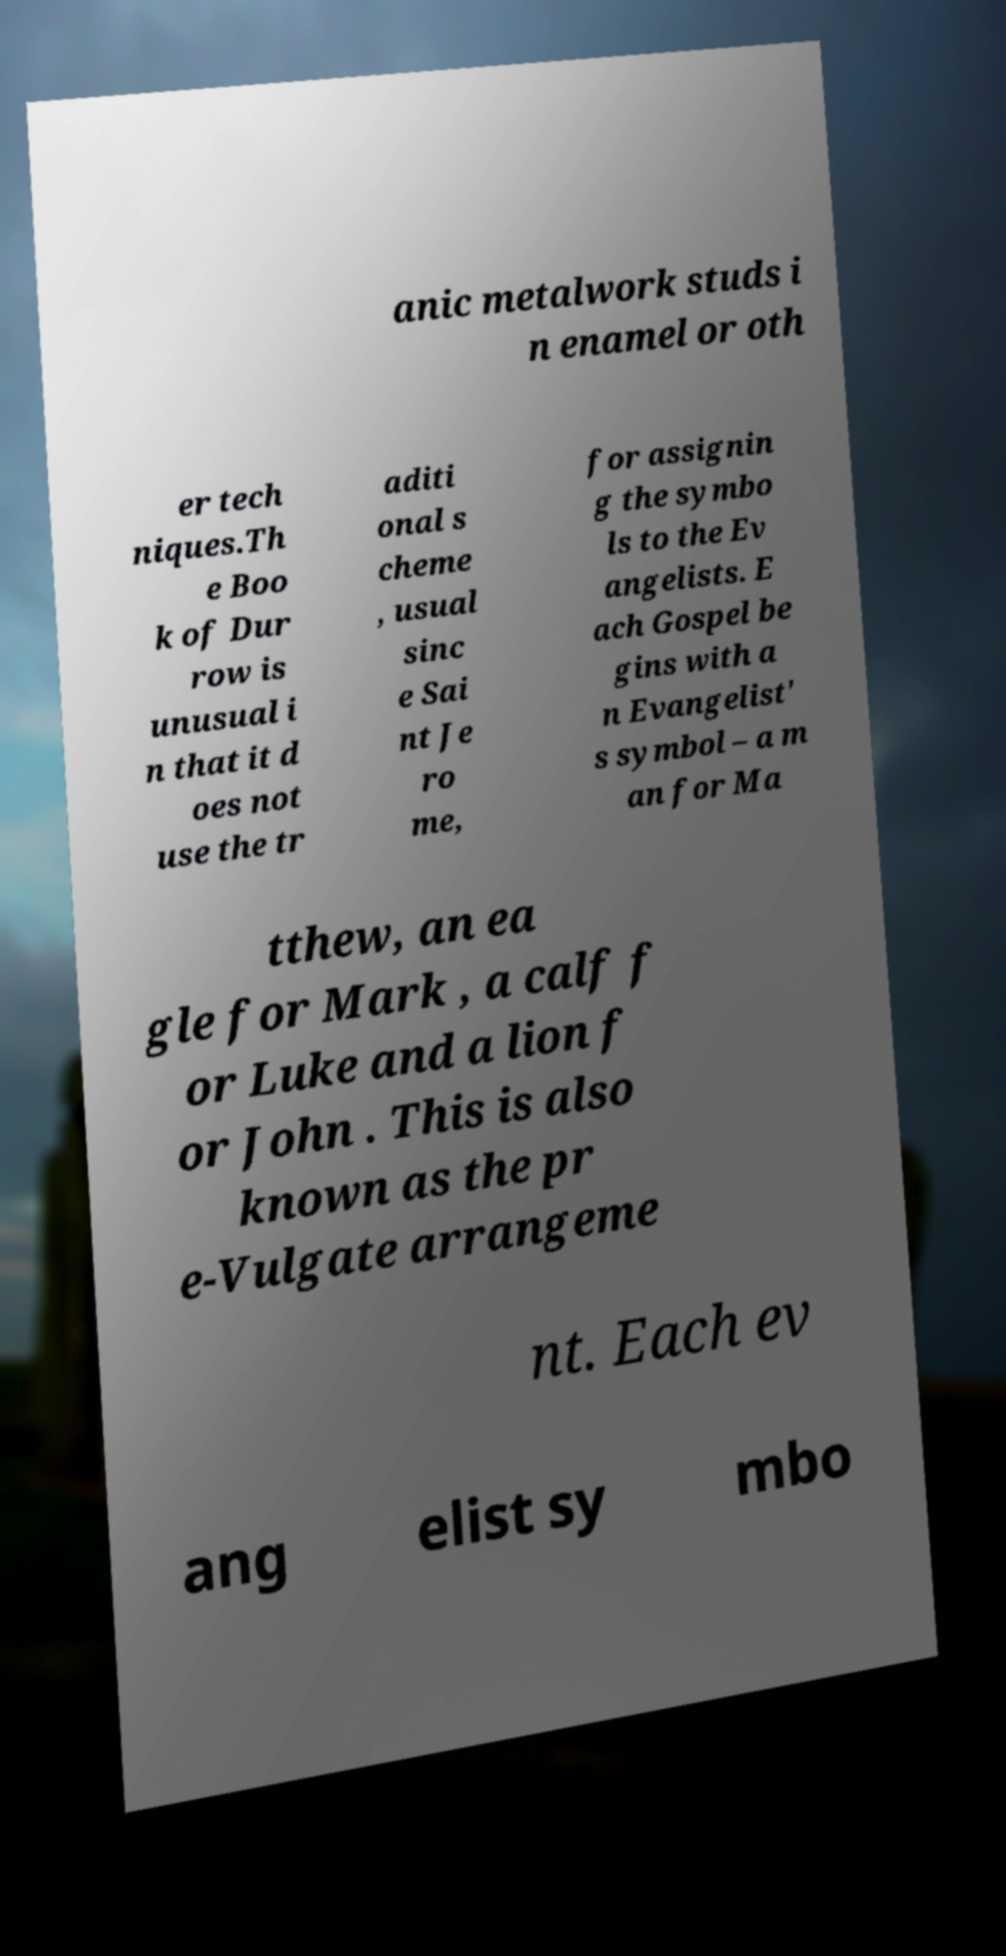Can you read and provide the text displayed in the image?This photo seems to have some interesting text. Can you extract and type it out for me? anic metalwork studs i n enamel or oth er tech niques.Th e Boo k of Dur row is unusual i n that it d oes not use the tr aditi onal s cheme , usual sinc e Sai nt Je ro me, for assignin g the symbo ls to the Ev angelists. E ach Gospel be gins with a n Evangelist' s symbol – a m an for Ma tthew, an ea gle for Mark , a calf f or Luke and a lion f or John . This is also known as the pr e-Vulgate arrangeme nt. Each ev ang elist sy mbo 